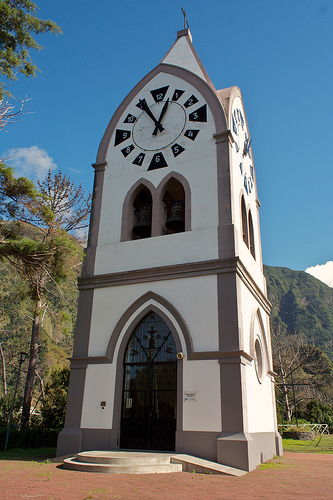What is in front of the green hill? The clock tower stands in front of the green hill. 